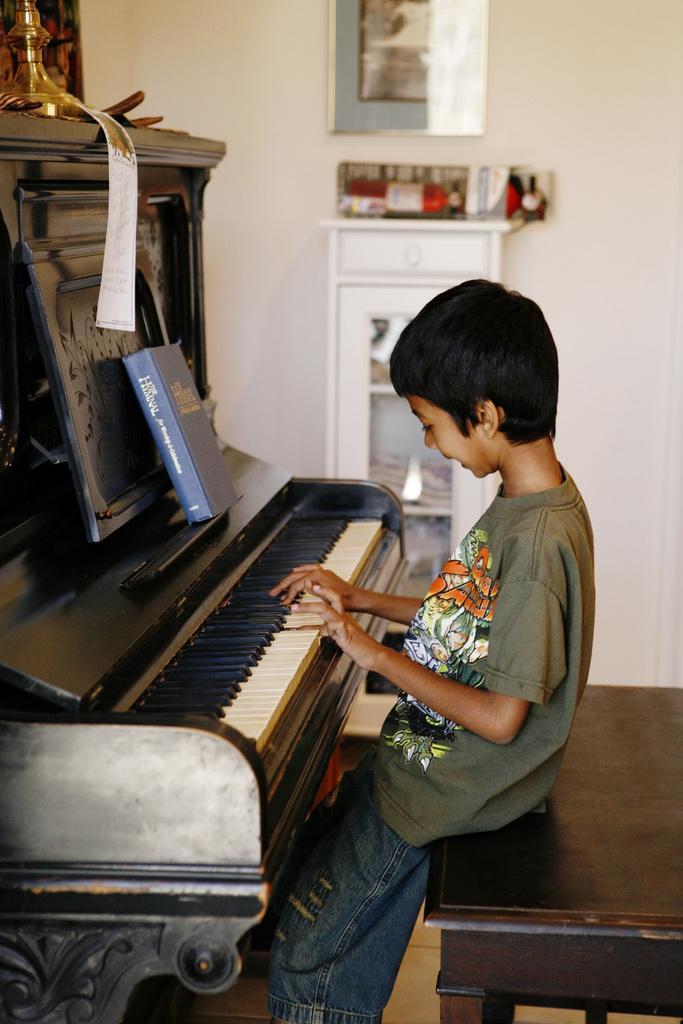Describe this image in one or two sentences. In this picture we can see boy sitting on table and playing piano and on piano we can see book, paper and in background we can see cupboard with racks, wall with frames. 